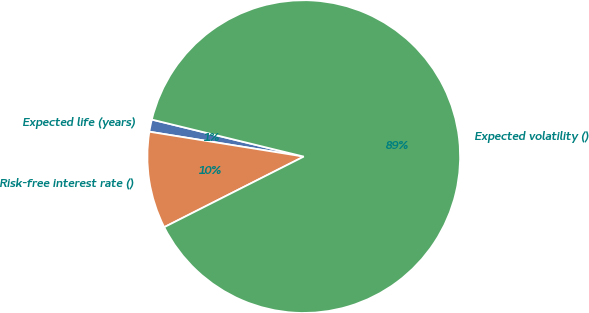Convert chart to OTSL. <chart><loc_0><loc_0><loc_500><loc_500><pie_chart><fcel>Expected life (years)<fcel>Risk-free interest rate ()<fcel>Expected volatility ()<nl><fcel>1.26%<fcel>10.0%<fcel>88.74%<nl></chart> 